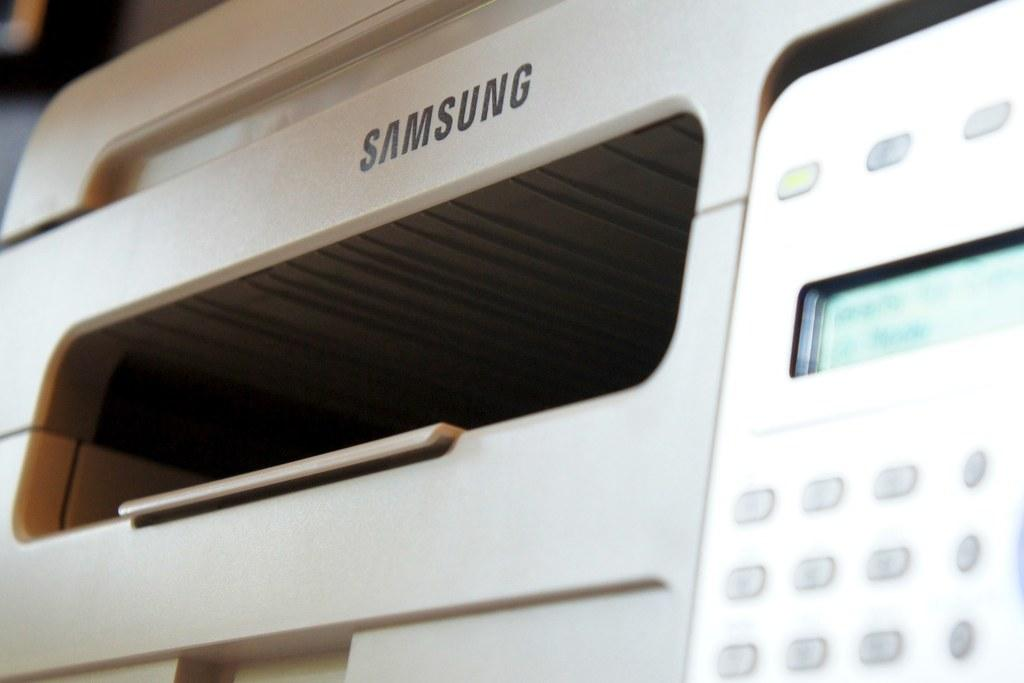What is the main object in the image? There is a machine tool in the image. What can be found on the right side of the machine tool? There are key buttons on the right side of the machine tool. How many buns are placed on top of the machine tool in the image? There are no buns present in the image; it features a machine tool with key buttons on the right side. What ideas can be generated from the machine tool in the image? The image does not convey any specific ideas or concepts; it simply shows a machine tool with key buttons. 